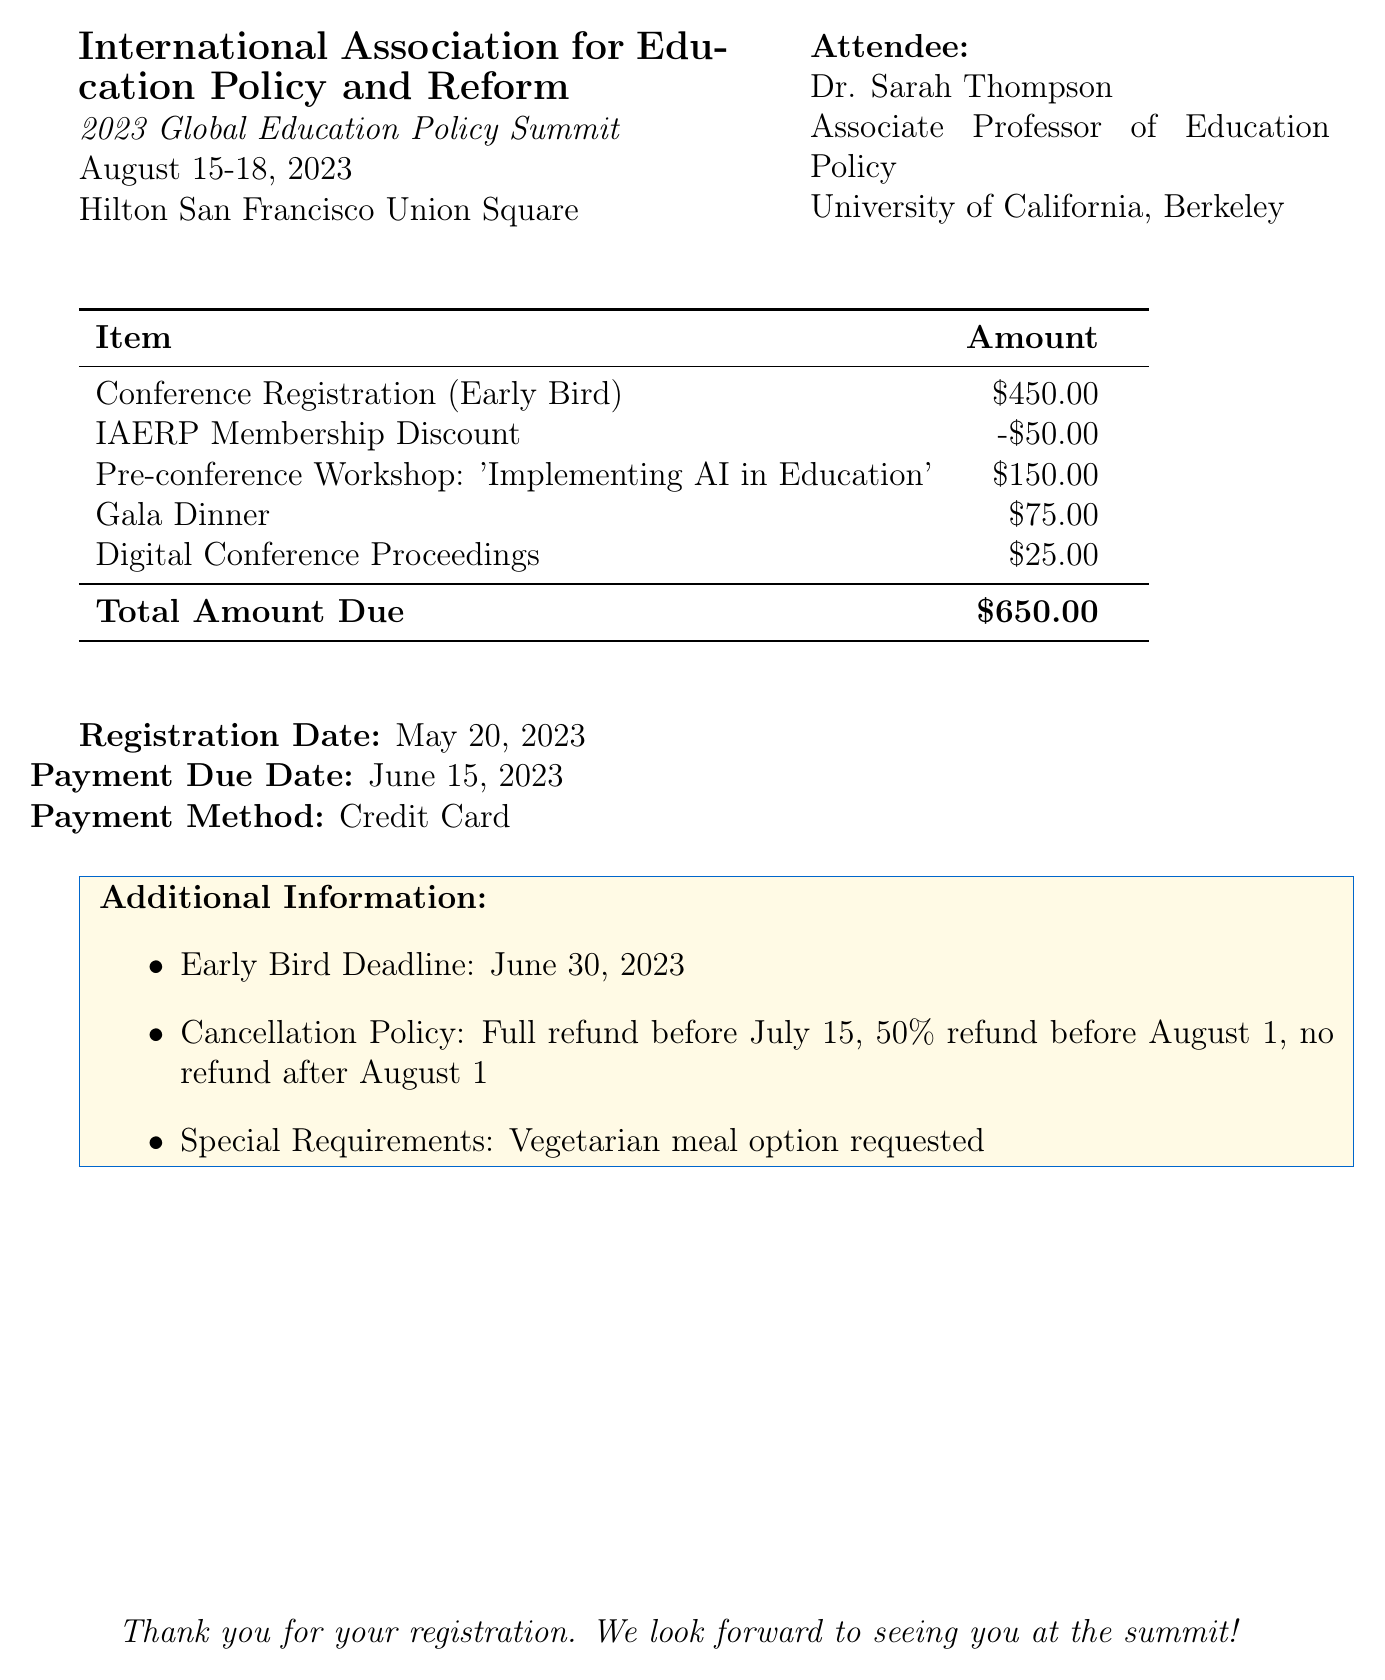what is the name of the conference? The conference name is mentioned in the document as "2023 Global Education Policy Summit."
Answer: 2023 Global Education Policy Summit who is the organizer of the conference? The organizer of the conference is listed in the document.
Answer: International Association for Education Policy and Reform what is the total amount due? The total amount due is specified in the invoice as the final amount after discounts and additional fees.
Answer: $650.00 what is the registration date? The invoice provides the registration date, indicating when the attendee registered for the conference.
Answer: May 20, 2023 how much was the early bird registration fee? The fee for early bird registration is broken down in the fee structure section.
Answer: $450.00 what is the cancellation policy for the conference? The cancellation policy details are included in the additional information section of the invoice.
Answer: Full refund before July 15, 50% refund before August 1, no refund after August 1 what is the payment due date? The payment due date is explicitly mentioned in the document and is critical for timely payment.
Answer: June 15, 2023 how much is the IAERP membership discount? The discount related to membership is specified in the fee breakdown.
Answer: -$50.00 what is the location of the conference? The location of the conference is indicated in the header section of the document.
Answer: Hilton San Francisco Union Square 